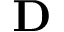<formula> <loc_0><loc_0><loc_500><loc_500>D</formula> 